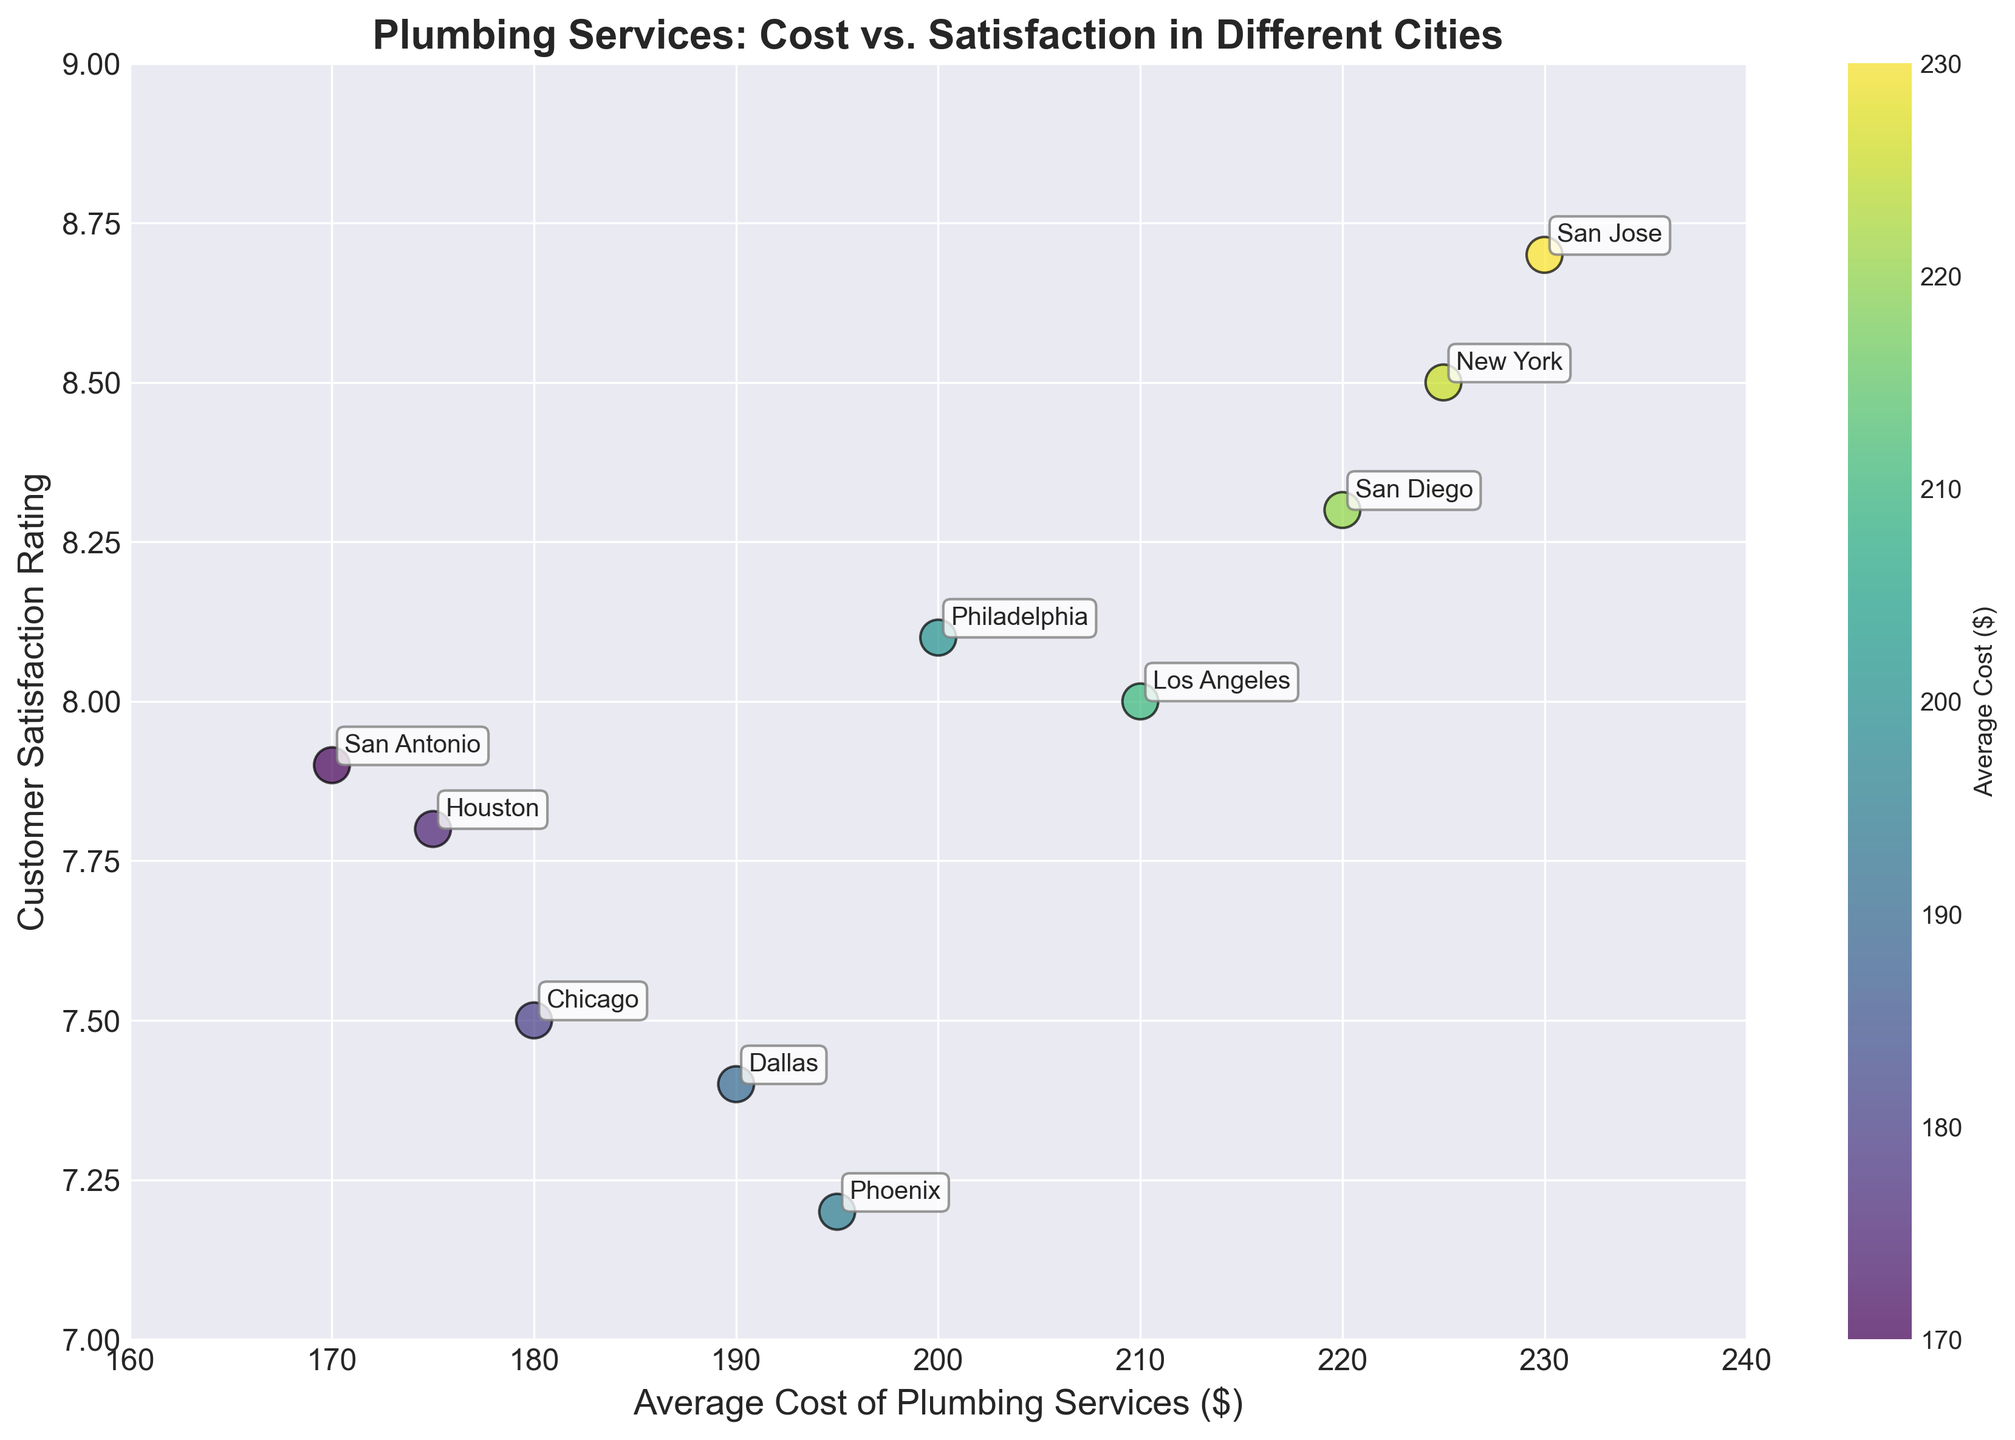what city has the highest average cost of plumbing services? The city with the highest average cost will be the data point at the far right of the x-axis (average cost).
Answer: San Jose What's the average cost of plumbing services for the city with the lowest customer satisfaction rating? Locate the point with the lowest position on the y-axis (Customer Satisfaction), and check its corresponding average cost on the x-axis.
Answer: Phoenix Which city has the highest customer satisfaction rating? The data point highest on the y-axis represents the highest customer satisfaction rating.
Answer: San Jose How many cities have an average cost of plumbing services above $200? Identify and count the number of points that are located to the right of the $200 mark on the x-axis.
Answer: 5 Is there a general trend between the average cost of plumbing services and customer satisfaction ratings? Observe the overall direction of the scatter plot points; they appear to form an upward trend, suggesting a positive correlation.
Answer: Positive correlation Which cities have a customer satisfaction rating of 8.0 or higher but an average cost of less than $230? Identify points that have a y-value of 8.0 or higher and an x-value less than $230.
Answer: New York, Los Angeles, Philadelphia, San Diego, San Antonio Which city has a higher customer satisfaction rating, Phoenix or Dallas? Compare the y-axis positions of the points labeled Phoenix and Dallas.
Answer: Dallas What is the average cost of plumbing services in cities with a customer satisfaction rating above 8.0? Locate the points with y-values above 8.0, sum their x-values, and divide by the number of these points. Calculation: (225 + 210 + 200 + 220 + 230)/5 = 217
Answer: 217 What is the customer satisfaction rating for the city with the third-highest average cost? Arrange cities by their average costs in descending order, identify the third city, and find its corresponding y-value.
Answer: New York with a rating of 8.5 Which city has a higher average cost, Philadelphia or Houston? Compare the x-axis positions of Philadelphia and Houston.
Answer: Philadelphia 